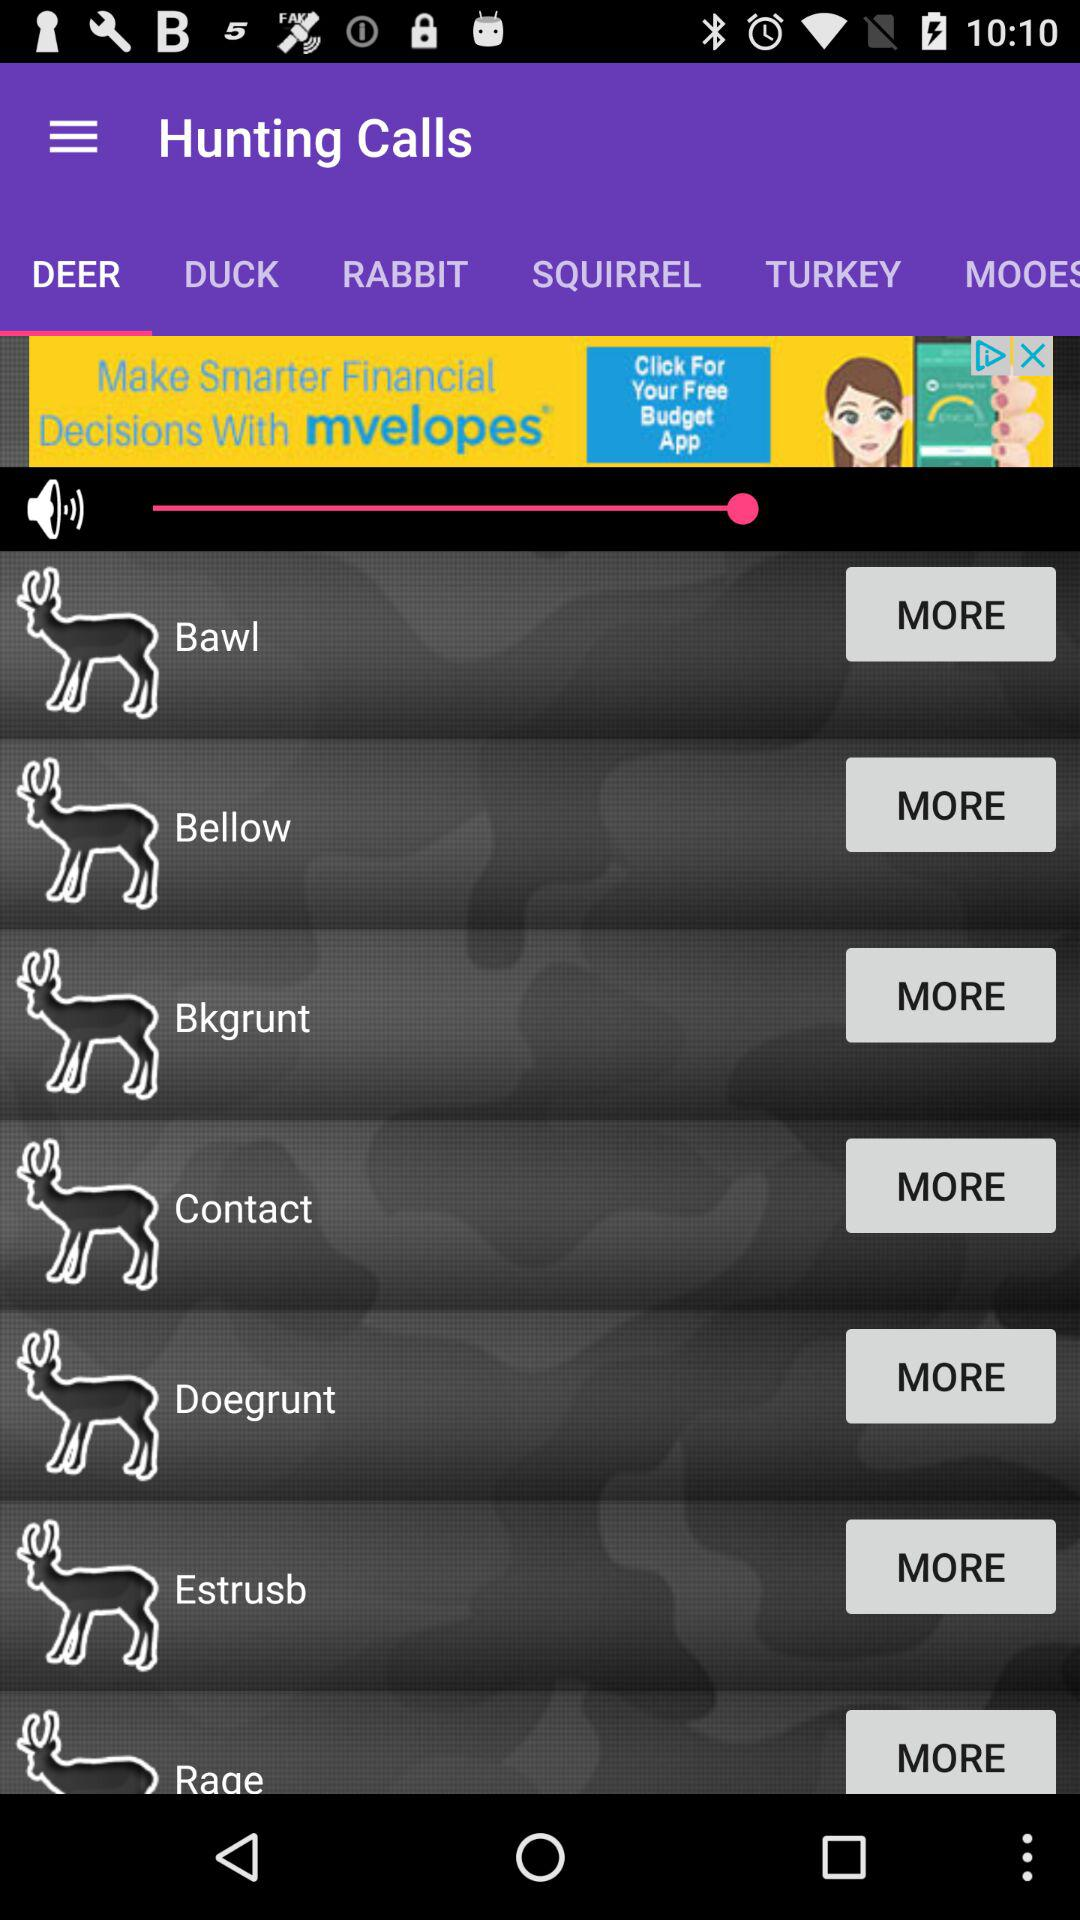What is the application name? The application name is "Hunting Calls". 